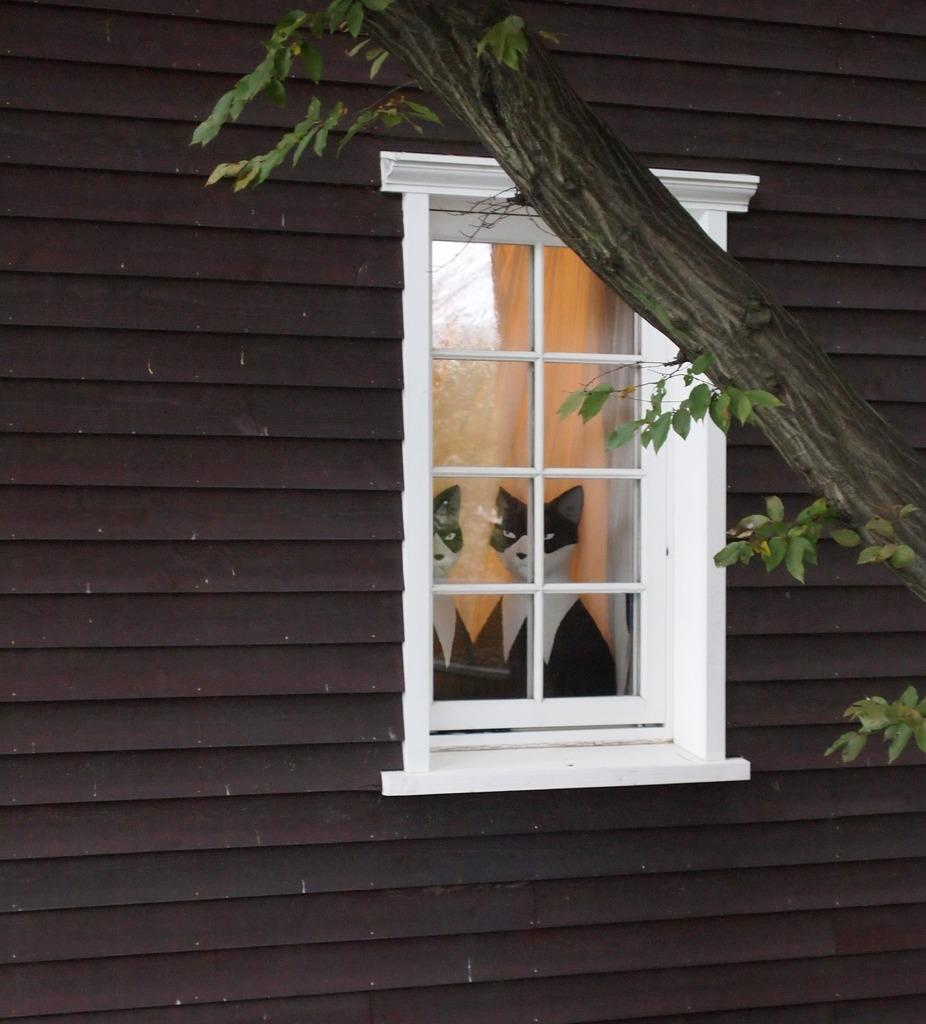What is located in the center of the image? There is a window in the center of the image. What can be seen through the window? A cat is visible through the window, as well as its reflection. What is visible in the background of the image? There is a wall and a tree in the background of the image. How many pizzas are being delivered to the person in the image? There is no person or pizza delivery present in the image. What type of eggs can be seen in the image? There are no eggs present in the image. 